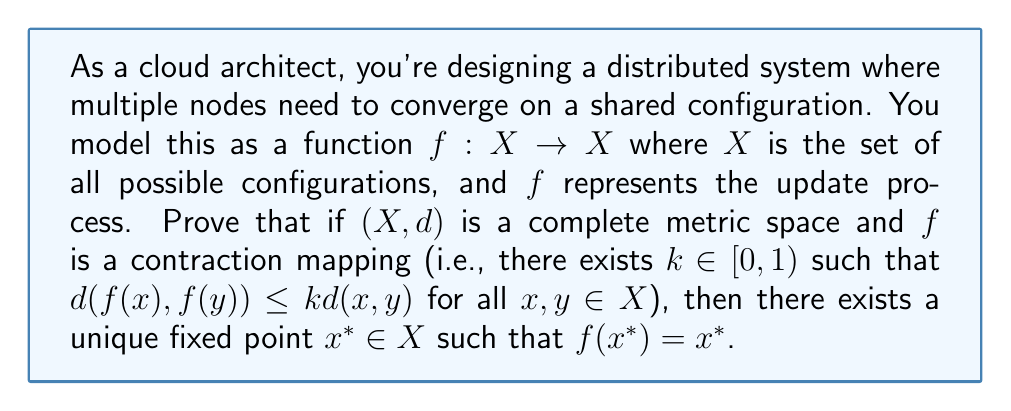Give your solution to this math problem. To prove the existence of a unique fixed point for a contractive mapping on a complete metric space, we'll use the Banach Fixed Point Theorem. Here's a step-by-step proof:

1) First, let's construct a sequence $\{x_n\}$ in $X$ defined by:
   $x_0 \in X$ (arbitrary starting point)
   $x_{n+1} = f(x_n)$ for $n \geq 0$

2) We'll prove that this sequence is Cauchy. For any $m > n$:
   $$\begin{align}
   d(x_m, x_n) &= d(f(x_{m-1}), f(x_{n-1})) \\
               &\leq kd(x_{m-1}, x_{n-1}) \\
               &\leq k^2d(x_{m-2}, x_{n-2}) \\
               &\vdots \\
               &\leq k^{m-n}d(x_n, x_0)
   \end{align}$$

3) Now, let's consider $d(x_n, x_0)$:
   $$\begin{align}
   d(x_n, x_0) &\leq d(x_n, x_{n-1}) + d(x_{n-1}, x_{n-2}) + ... + d(x_1, x_0) \\
               &\leq (k^{n-1} + k^{n-2} + ... + k + 1)d(x_1, x_0) \\
               &= \frac{1-k^n}{1-k}d(x_1, x_0)
   \end{align}$$

4) Combining steps 2 and 3:
   $$d(x_m, x_n) \leq k^{m-n}\frac{1-k^n}{1-k}d(x_1, x_0)$$

5) As $m,n \to \infty$, $k^{m-n} \to 0$ (since $k < 1$), so $d(x_m, x_n) \to 0$. This proves $\{x_n\}$ is Cauchy.

6) Since $X$ is complete, the Cauchy sequence $\{x_n\}$ converges to some $x^* \in X$.

7) Now we'll prove $x^*$ is a fixed point:
   $$\begin{align}
   d(f(x^*), x^*) &\leq d(f(x^*), f(x_n)) + d(f(x_n), x^*) \\
                  &\leq kd(x^*, x_n) + d(x_{n+1}, x^*)
   \end{align}$$
   As $n \to \infty$, both terms on the right approach 0, so $f(x^*) = x^*$.

8) For uniqueness, assume $y^*$ is another fixed point. Then:
   $$d(x^*, y^*) = d(f(x^*), f(y^*)) \leq kd(x^*, y^*)$$
   This is only possible if $d(x^*, y^*) = 0$, i.e., $x^* = y^*$.

Thus, we've proved the existence and uniqueness of the fixed point.
Answer: There exists a unique fixed point $x^* \in X$ such that $f(x^*) = x^*$. 